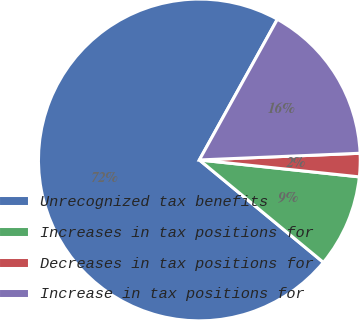Convert chart. <chart><loc_0><loc_0><loc_500><loc_500><pie_chart><fcel>Unrecognized tax benefits<fcel>Increases in tax positions for<fcel>Decreases in tax positions for<fcel>Increase in tax positions for<nl><fcel>72.07%<fcel>9.31%<fcel>2.34%<fcel>16.28%<nl></chart> 